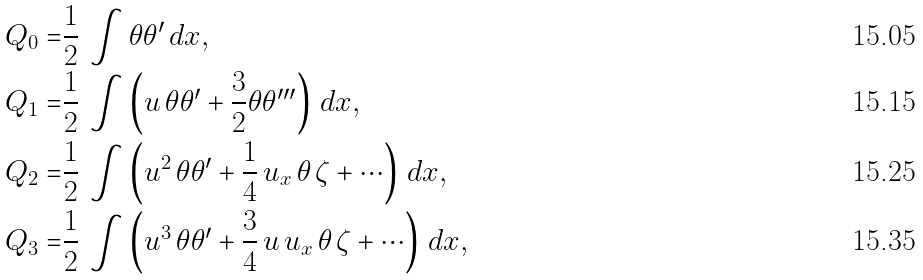Convert formula to latex. <formula><loc_0><loc_0><loc_500><loc_500>Q _ { 0 } = & \frac { 1 } { 2 } \, \int \theta \theta ^ { \prime } \, d x , \\ Q _ { 1 } = & \frac { 1 } { 2 } \, \int \left ( u \, \theta \theta ^ { \prime } + \frac { 3 } { 2 } \theta \theta ^ { \prime \prime \prime } \right ) \, d x , \\ Q _ { 2 } = & \frac { 1 } { 2 } \, \int \left ( u ^ { 2 } \, \theta \theta ^ { \prime } + \frac { 1 } { 4 } \, u _ { x } \, \theta \, \zeta + \cdots \right ) \, d x , \\ Q _ { 3 } = & \frac { 1 } { 2 } \, \int \left ( u ^ { 3 } \, \theta \theta ^ { \prime } + \frac { 3 } { 4 } \, u \, u _ { x } \, \theta \, \zeta + \cdots \right ) \, d x ,</formula> 